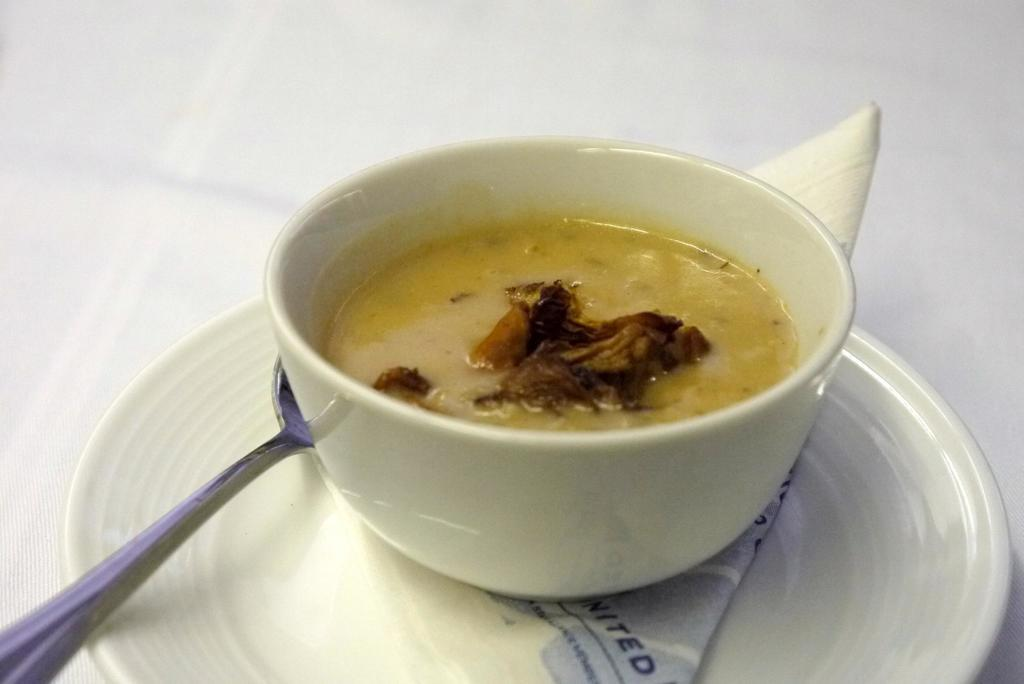What is the color of the cloth in the image? The cloth in the image is white. What type of dish is present in the image? There is food in a bowl in the image. What can be used for cleaning or wiping in the image? Tissue paper is present in the image. What is another dish-related item visible in the image? There is a plate in the image. What utensil is visible in the image? A spoon is visible in the image. What news is being discussed by the daughter in the image? There is no daughter present in the image, and no news is being discussed. What type of sidewalk can be seen in the image? There is no sidewalk present in the image. 